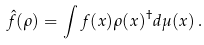<formula> <loc_0><loc_0><loc_500><loc_500>\hat { f } ( \rho ) = \int f ( x ) \rho ( x ) ^ { \dagger } d \mu ( x ) \, .</formula> 